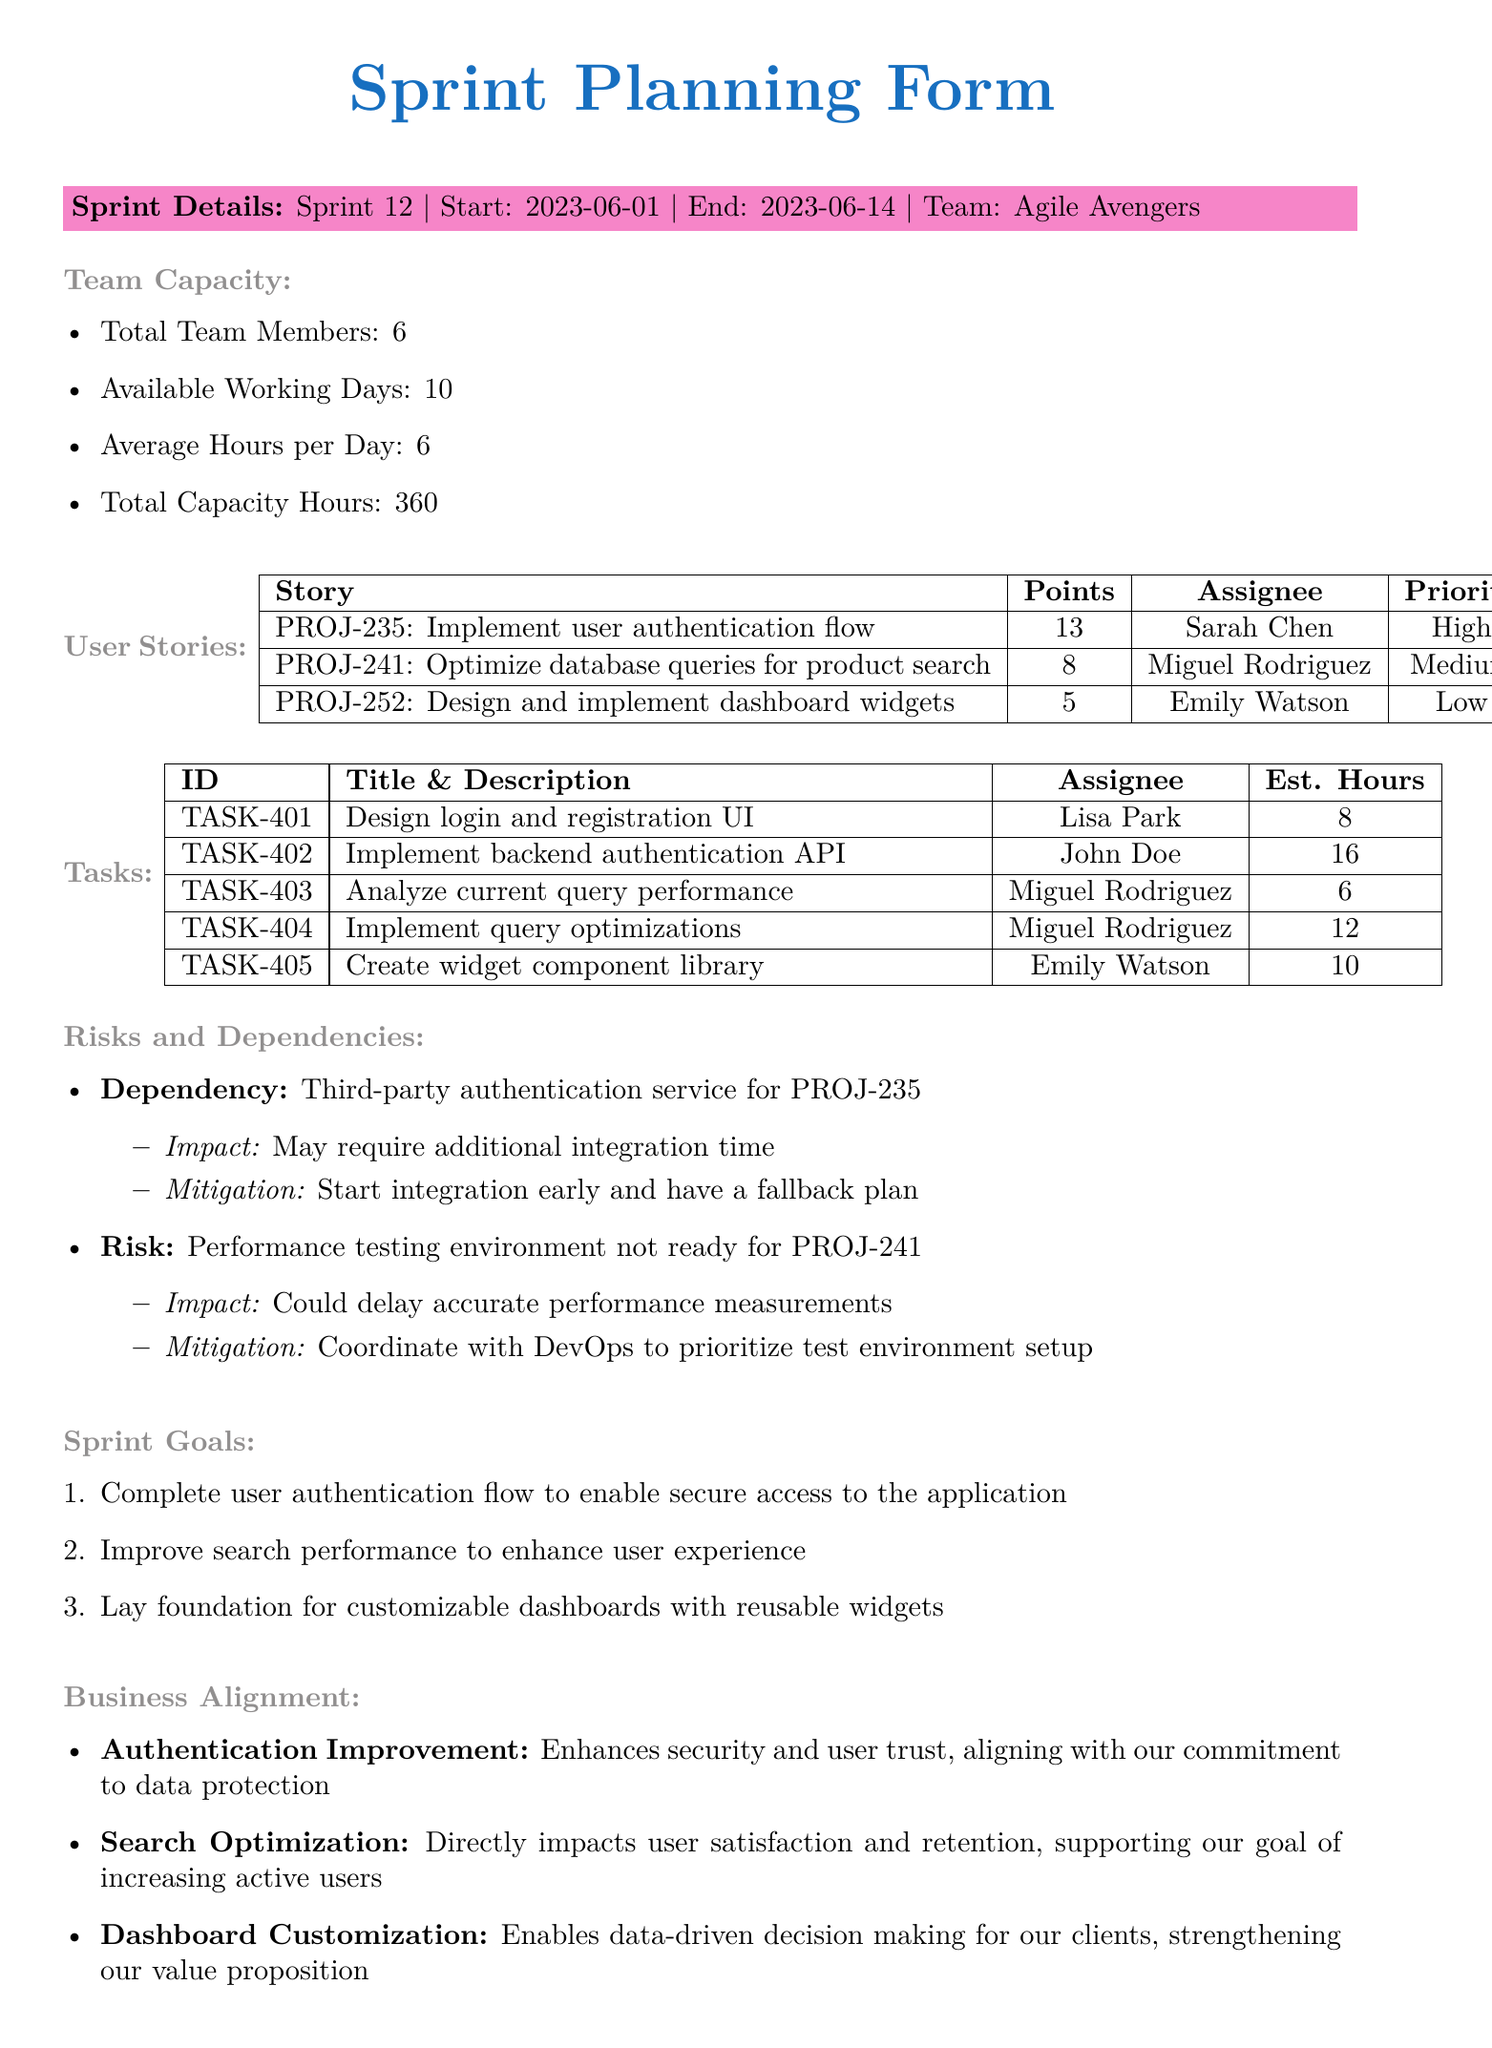what is the sprint number? The sprint number is specified in the document under sprint details.
Answer: 12 who is the assignee for task TASK-402? The assignee for task TASK-402 is listed in the tasks section of the document.
Answer: John Doe how many total team members are there? The total number of team members is given in the team capacity section of the document.
Answer: 6 what is the total capacity hours for the team? The total capacity hours can be found in the team capacity information.
Answer: 360 what is the priority of the story PROJ-241? The priority of story PROJ-241 is mentioned under the user stories section.
Answer: Medium which task has the highest estimated hours? The task with the highest estimated hours is identified from the list of tasks in the document.
Answer: Implement backend authentication API how many hours are estimated for creating the widget component library? The estimated hours for this specific task are provided in the tasks section of the document.
Answer: 10 what is the impact of the dependency on the third-party authentication service? The impact is detailed in the risks and dependencies section of the document.
Answer: May require additional integration time what is the first sprint goal? The first sprint goal is outlined in the sprint goals section of the document.
Answer: Complete user authentication flow to enable secure access to the application 